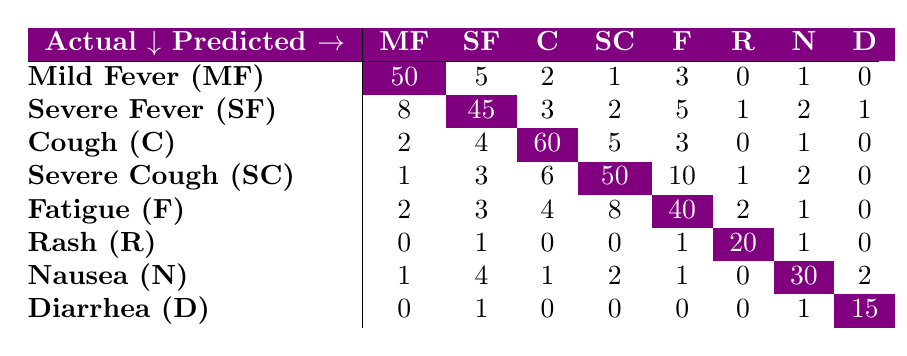What is the predicted count for Mild Fever when the actual condition is Severe Cough? In the table, we look under the Severe Cough row and find the column for Mild Fever, which shows a predicted count of 1.
Answer: 1 What is the total number of predictions for patients with Cough? To find the total predictions for Cough, we sum all values in the Cough row: 2 (MF) + 4 (SF) + 60 (C) + 5 (SC) + 3 (F) + 0 (R) + 1 (N) + 0 (D) = 75.
Answer: 75 Is it true that more patients were predicted to have Fatigue than Severe Fever? To verify this, we compare the values: Fatigue has a predicted count of 40, while Severe Fever has 45. Since 40 is less than 45, the statement is false.
Answer: No What is the sum of all predicted counts for Diarrhea? Looking at the Diarrhea row, we sum each value: 0 (MF) + 1 (SF) + 0 (C) + 0 (SC) + 0 (F) + 0 (R) + 1 (N) + 15 (D) = 17.
Answer: 17 What is the predicted count for Severe Fever when the actual condition is Mild Fever? In the Mild Fever row, we find the corresponding value for Severe Fever, which is 5.
Answer: 5 What is the percentage of correct predictions for Nausea? The accurate prediction for Nausea is represented by the number in the Nausea row and Nausea column, which is 30. The total predictions for Nausea is 30 + 1 + 2 + 1 + 1 + 0 + 4 = 40. The percentage correct is (30/40) * 100 = 75%.
Answer: 75% How many misclassifications occurred for Rash? We find the values in the Rash row, excluding the prediction for Rash itself (20). Adding the rest gives: 0 (MF) + 1 (SF) + 0 (C) + 0 (SC) + 1 (F) + 1 (N) + 0 (D) = 3 misclassifications.
Answer: 3 Which symptom shows the lowest predicted count, and what is that count? By looking across all the rows and counting, we find that Rash has a count of 20, which is the lowest among all symptoms.
Answer: 20 What is the overall trend in the predictions for Severe Cough compared to Cough? Looking at the counts, Severe Cough has 50 predicted instances while Cough has 60. This indicates that Severe Cough predictions are slightly lower than those for Cough.
Answer: Lower 